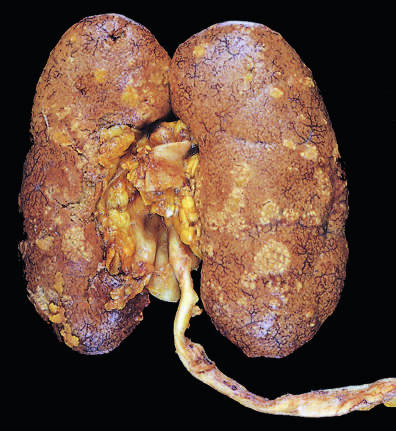what is there between the abscesses?
Answer the question using a single word or phrase. Dark congestion of the renal surface 